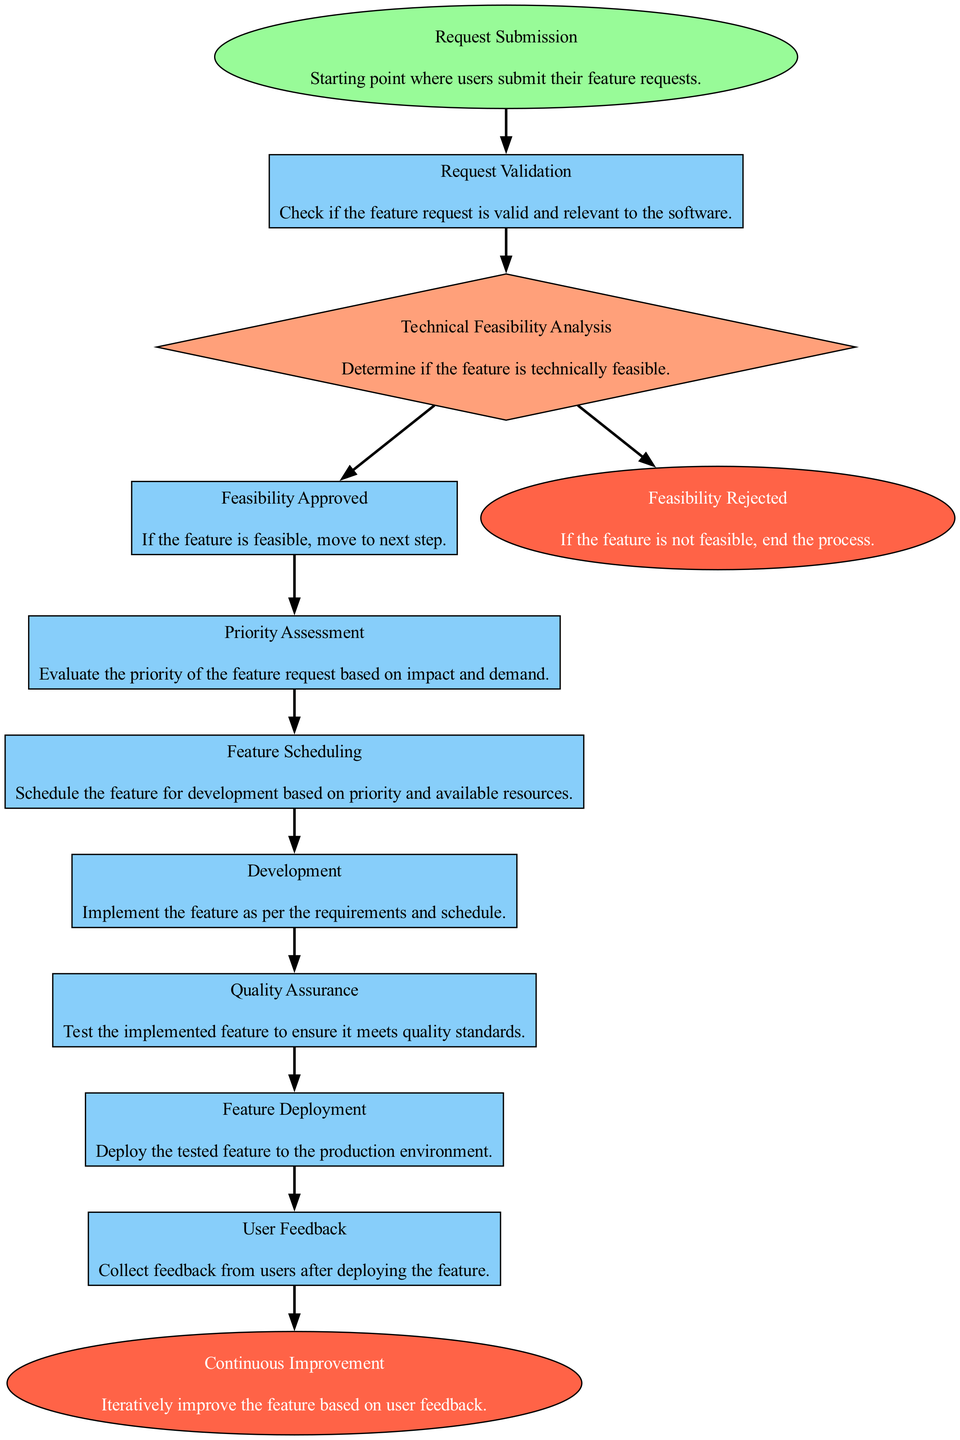What is the starting point of the workflow? The starting point is indicated as "Request Submission" in the diagram, representing where users initiate the process by submitting their feature requests.
Answer: Request Submission How many process nodes are in the workflow? The process nodes are "Request Validation," "Feasibility Approved," "Priority Assessment," "Feature Scheduling," "Development," "Quality Assurance," "Feature Deployment," and "User Feedback." There are a total of 8 process nodes counted in the diagram.
Answer: 8 What happens if the technical feasibility is rejected? In the diagram, if the technical feasibility is not approved, the workflow moves to "Feasibility Rejected," which is the endpoint of the process, indicating that the feature request will not proceed further.
Answer: Feasibility Rejected Which node follows the "Technical Feasibility Analysis"? The node that directly follows "Technical Feasibility Analysis" is "Feasibility Approved," indicating that only if the feature is deemed feasible does it proceed to the next step.
Answer: Feasibility Approved What is the final step in the feature request handling process? The final step as shown in the diagram is "Continuous Improvement," which wraps up the process by iteratively enhancing the feature based on user feedback.
Answer: Continuous Improvement What connects "Quality Assurance" to "Feature Deployment"? The connection is an edge in the diagram indicating that once the feature passes quality assurance testing, it is subsequently deployed into the production environment.
Answer: Feature Deployment What is evaluated in the "Priority Assessment" node? The "Priority Assessment" node evaluates the priority of a feature request based on its impact and demand, determining how crucial it is to implement the feature in the development roadmap.
Answer: Priority of the feature request What decisions are made during the "Technical Feasibility Analysis"? During this node, a decision is made regarding the feasibility of the feature. The outcomes of this decision are either "Feasibility Approved," allowing advancement, or "Feasibility Rejected," leading to the termination of the process.
Answer: Feasibility Approved or Feasibility Rejected 